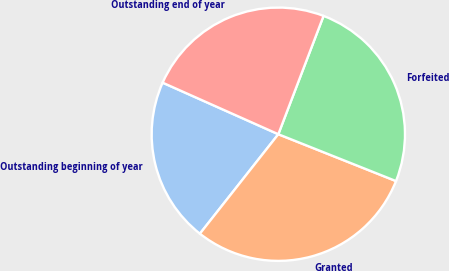Convert chart. <chart><loc_0><loc_0><loc_500><loc_500><pie_chart><fcel>Outstanding beginning of year<fcel>Granted<fcel>Forfeited<fcel>Outstanding end of year<nl><fcel>21.05%<fcel>29.6%<fcel>25.22%<fcel>24.14%<nl></chart> 